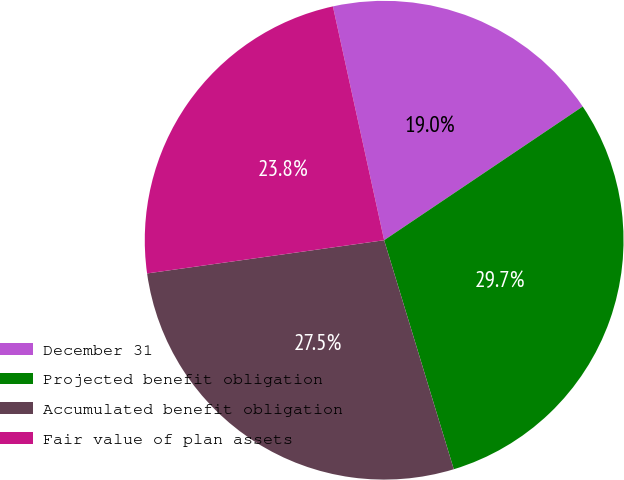<chart> <loc_0><loc_0><loc_500><loc_500><pie_chart><fcel>December 31<fcel>Projected benefit obligation<fcel>Accumulated benefit obligation<fcel>Fair value of plan assets<nl><fcel>19.0%<fcel>29.73%<fcel>27.48%<fcel>23.78%<nl></chart> 